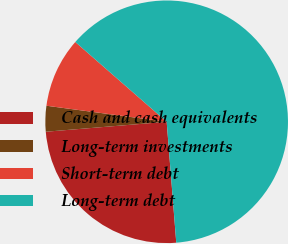Convert chart. <chart><loc_0><loc_0><loc_500><loc_500><pie_chart><fcel>Cash and cash equivalents<fcel>Long-term investments<fcel>Short-term debt<fcel>Long-term debt<nl><fcel>24.95%<fcel>3.42%<fcel>9.31%<fcel>62.31%<nl></chart> 